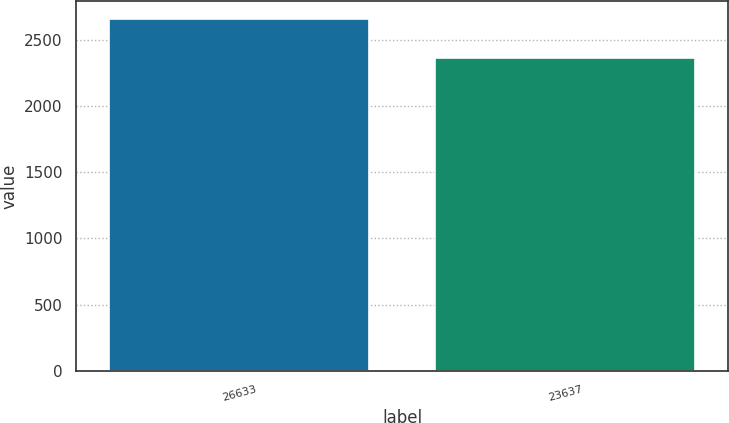Convert chart. <chart><loc_0><loc_0><loc_500><loc_500><bar_chart><fcel>26633<fcel>23637<nl><fcel>2656.3<fcel>2360.9<nl></chart> 